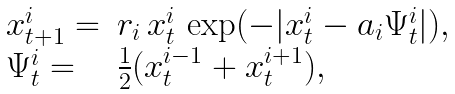Convert formula to latex. <formula><loc_0><loc_0><loc_500><loc_500>\begin{array} { l l } x _ { t + 1 } ^ { i } = & r _ { i } \, x _ { t } ^ { i } \, \exp ( - | x _ { t } ^ { i } - a _ { i } \Psi _ { t } ^ { i } | ) , \\ \Psi _ { t } ^ { i } = & \frac { 1 } { 2 } ( x ^ { i - 1 } _ { t } + x ^ { i + 1 } _ { t } ) , \end{array}</formula> 